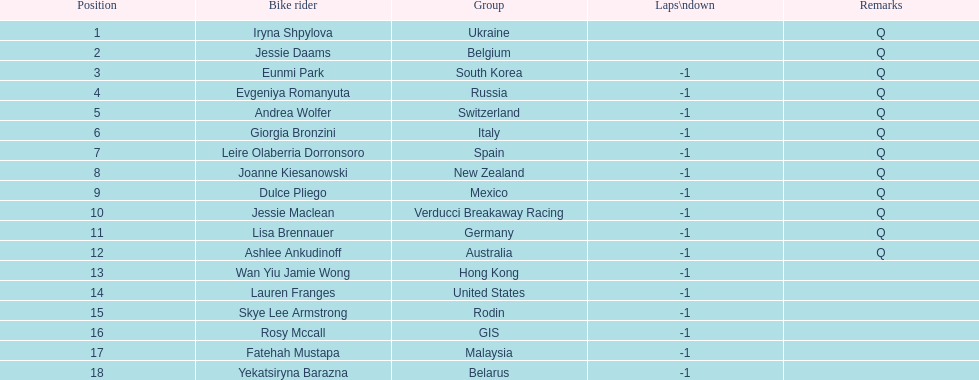Who was the top ranked competitor in this race? Iryna Shpylova. 